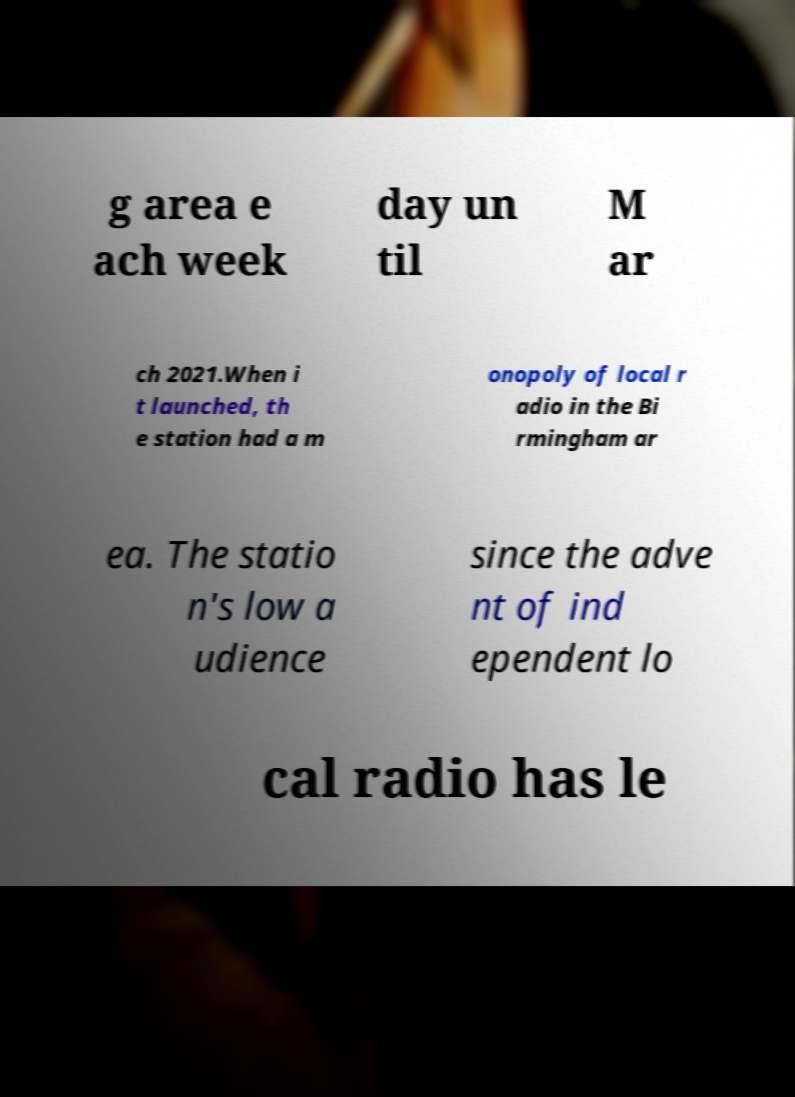Can you read and provide the text displayed in the image?This photo seems to have some interesting text. Can you extract and type it out for me? g area e ach week day un til M ar ch 2021.When i t launched, th e station had a m onopoly of local r adio in the Bi rmingham ar ea. The statio n's low a udience since the adve nt of ind ependent lo cal radio has le 